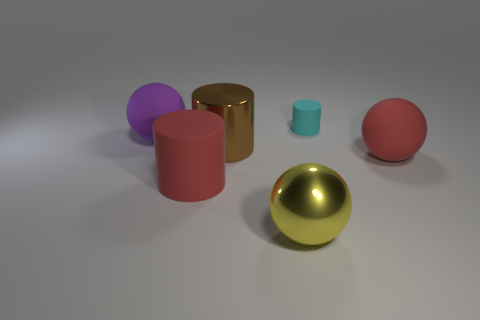Add 1 red cylinders. How many objects exist? 7 Add 6 red rubber balls. How many red rubber balls are left? 7 Add 3 rubber spheres. How many rubber spheres exist? 5 Subtract 0 yellow cubes. How many objects are left? 6 Subtract all big brown things. Subtract all red cylinders. How many objects are left? 4 